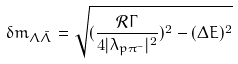<formula> <loc_0><loc_0><loc_500><loc_500>\delta m _ { \Lambda \bar { \Lambda } } = \sqrt { ( \frac { \mathcal { R } \Gamma } { 4 | \lambda _ { p \pi ^ { - } } | ^ { 2 } } ) ^ { 2 } - ( \Delta E ) ^ { 2 } }</formula> 